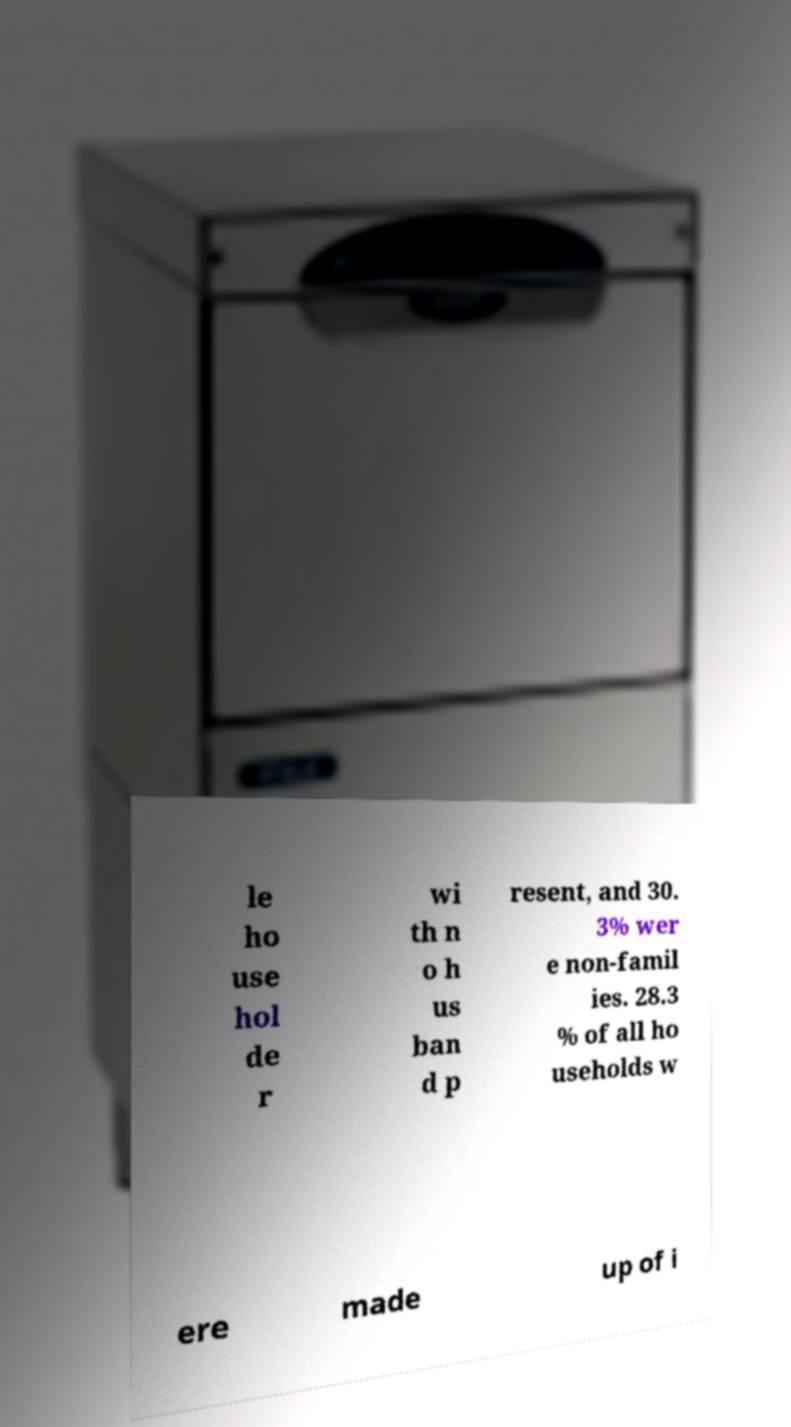There's text embedded in this image that I need extracted. Can you transcribe it verbatim? le ho use hol de r wi th n o h us ban d p resent, and 30. 3% wer e non-famil ies. 28.3 % of all ho useholds w ere made up of i 